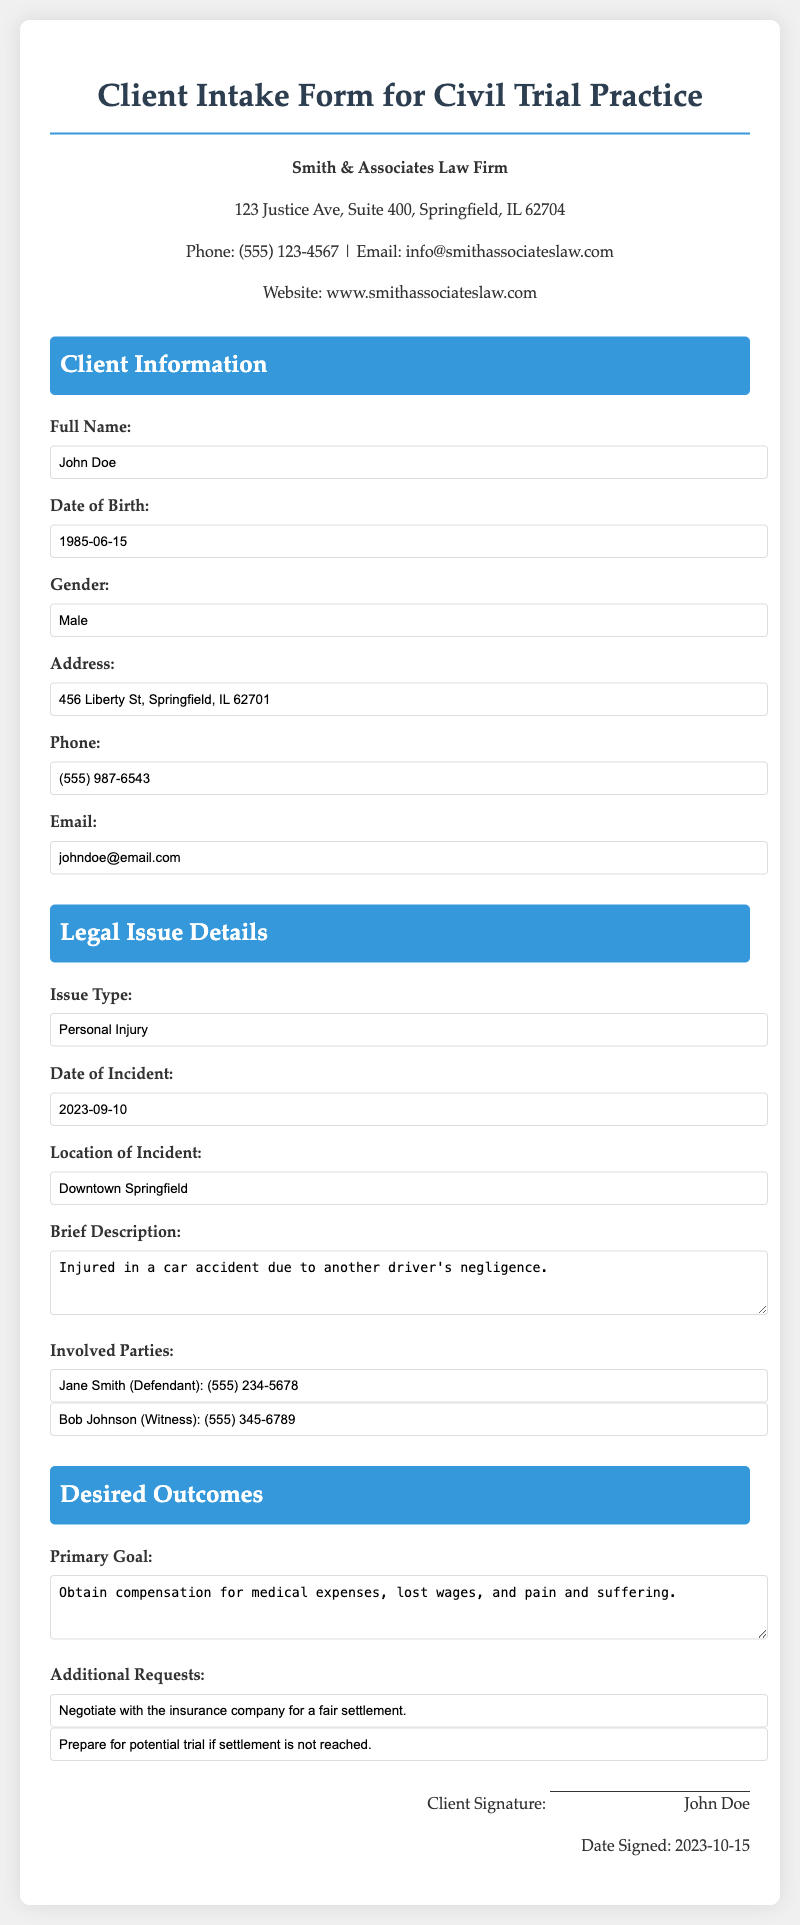What is the full name of the client? The client's full name is stated in the Client Information section of the form.
Answer: John Doe What is the client's date of birth? The date of birth can be found in the Client Information section, where personal details are recorded.
Answer: 1985-06-15 What is the primary legal issue type? The issue type is specified in the Legal Issue Details section of the document.
Answer: Personal Injury When did the incident occur? The date of the incident is listed under Legal Issue Details, showing when the event took place.
Answer: 2023-09-10 What is the client's primary goal? The primary goal is detailed in the Desired Outcomes section of the form, outlining what the client wants to achieve.
Answer: Obtain compensation for medical expenses, lost wages, and pain and suffering Who is the defendant involved in the case? The involved parties section lists the individuals related to the client's legal issue, where the defendant is mentioned.
Answer: Jane Smith What additional request does the client have? This can be found in the Desired Outcomes section, which captures the client's specific requests pertaining to the case.
Answer: Negotiate with the insurance company for a fair settlement What is the location of the incident? The location is provided in the Legal Issue Details section, offering context about where the incident took place.
Answer: Downtown Springfield What is the signature date? The signature date is indicated in the signature area at the bottom of the document, marking when the client agreed to the form.
Answer: 2023-10-15 